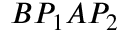Convert formula to latex. <formula><loc_0><loc_0><loc_500><loc_500>B P _ { 1 } A P _ { 2 }</formula> 